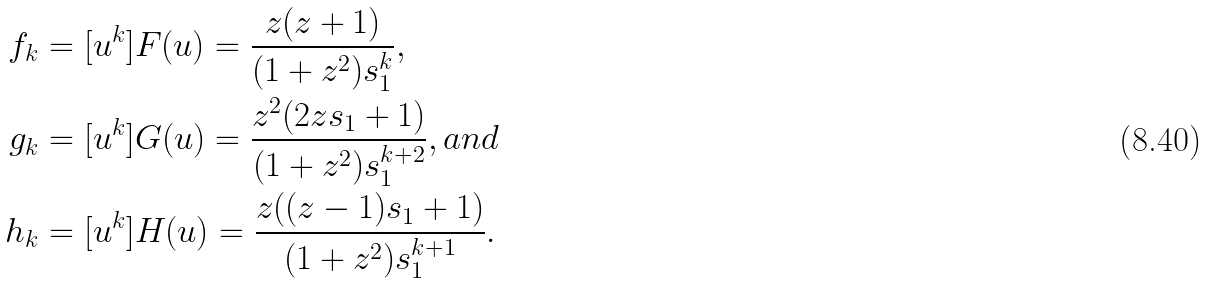Convert formula to latex. <formula><loc_0><loc_0><loc_500><loc_500>f _ { k } & = [ u ^ { k } ] F ( u ) = \frac { z ( z + 1 ) } { ( 1 + z ^ { 2 } ) s _ { 1 } ^ { k } } , \\ g _ { k } & = [ u ^ { k } ] G ( u ) = \frac { z ^ { 2 } ( 2 z s _ { 1 } + 1 ) } { ( 1 + z ^ { 2 } ) s _ { 1 } ^ { k + 2 } } , a n d \\ h _ { k } & = [ u ^ { k } ] H ( u ) = \frac { z ( ( z - 1 ) s _ { 1 } + 1 ) } { ( 1 + z ^ { 2 } ) s _ { 1 } ^ { k + 1 } } .</formula> 